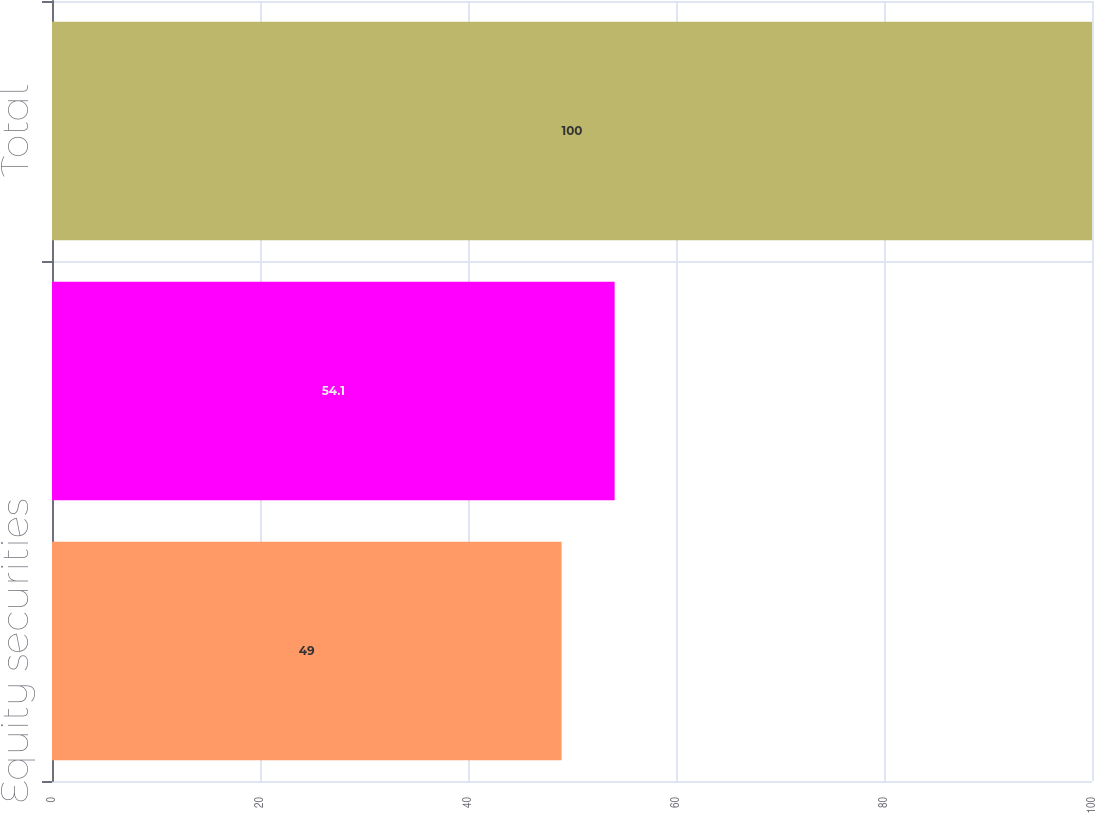<chart> <loc_0><loc_0><loc_500><loc_500><bar_chart><fcel>Equity securities<fcel>Debt securities<fcel>Total<nl><fcel>49<fcel>54.1<fcel>100<nl></chart> 